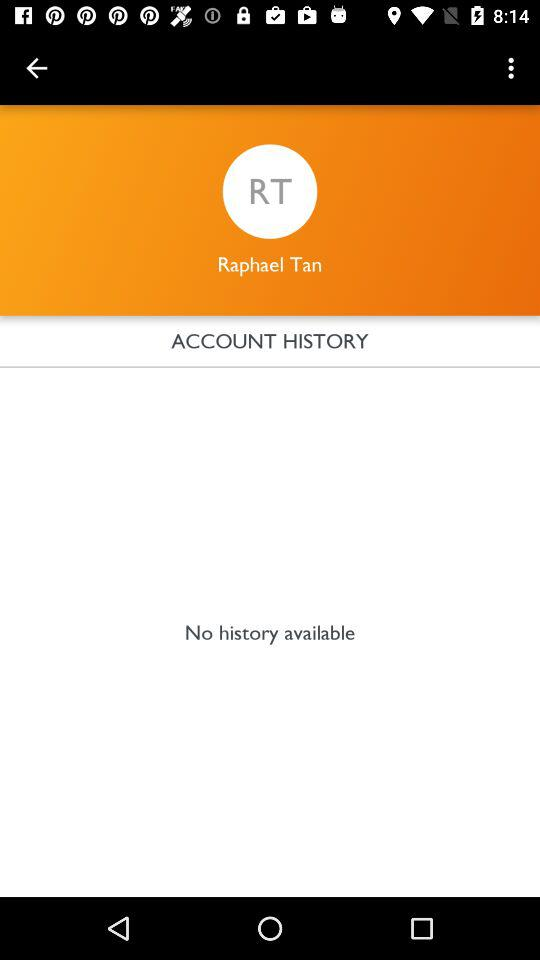How much is the next transaction?
When the provided information is insufficient, respond with <no answer>. <no answer> 